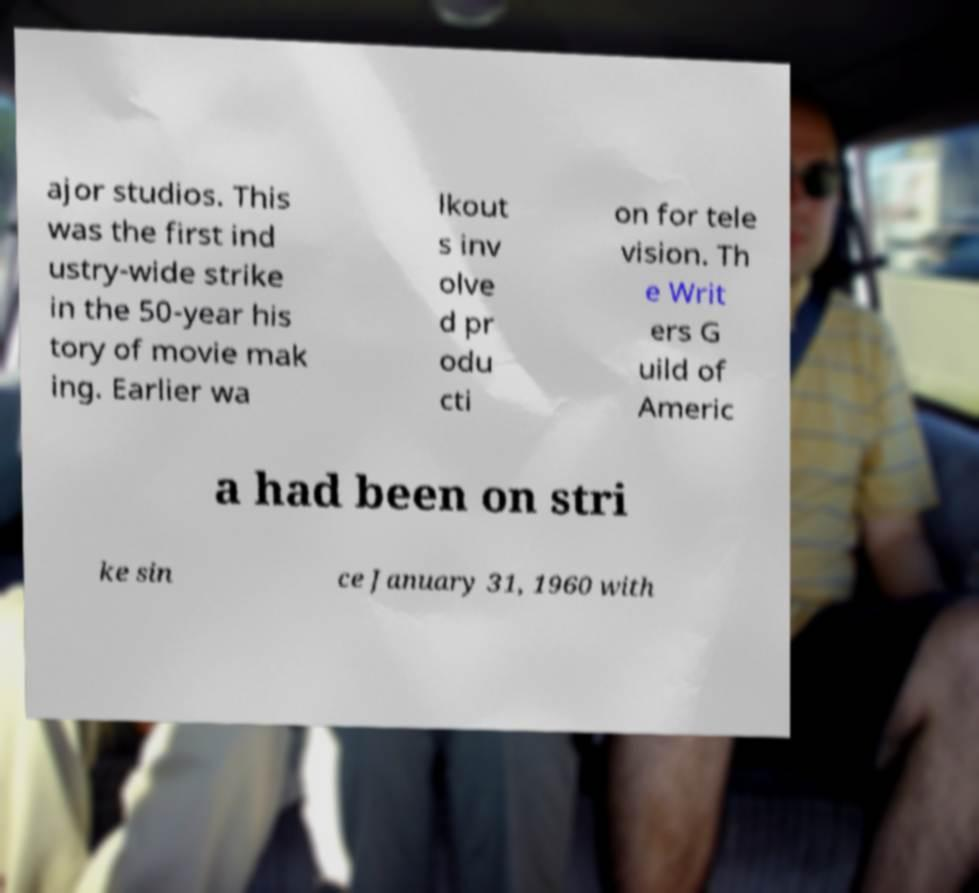Please read and relay the text visible in this image. What does it say? ajor studios. This was the first ind ustry-wide strike in the 50-year his tory of movie mak ing. Earlier wa lkout s inv olve d pr odu cti on for tele vision. Th e Writ ers G uild of Americ a had been on stri ke sin ce January 31, 1960 with 